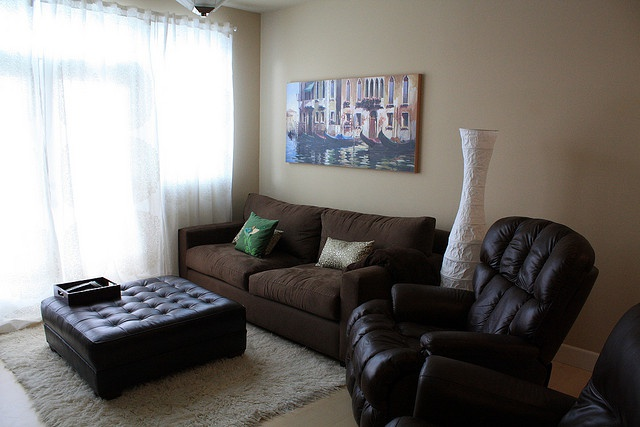Describe the objects in this image and their specific colors. I can see chair in lightblue, black, and gray tones, couch in lightblue, black, and gray tones, couch in lightblue, black, and gray tones, chair in lightblue, black, maroon, and gray tones, and vase in lightblue, gray, darkgray, and lavender tones in this image. 